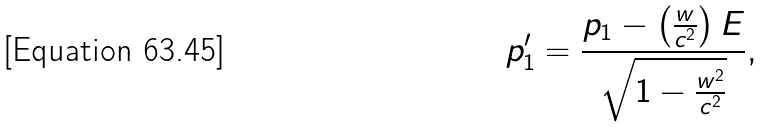Convert formula to latex. <formula><loc_0><loc_0><loc_500><loc_500>p _ { 1 } ^ { \prime } = \frac { p _ { 1 } - \left ( \frac { w } { c ^ { 2 } } \right ) E } { \sqrt { 1 - \frac { w ^ { 2 } } { c ^ { 2 } } } } ,</formula> 